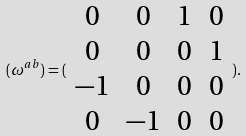<formula> <loc_0><loc_0><loc_500><loc_500>( \omega ^ { a b } ) = ( \begin{array} { c c c c } 0 & 0 & 1 & 0 \\ 0 & 0 & 0 & 1 \\ - 1 & 0 & 0 & 0 \\ 0 & - 1 & 0 & 0 \end{array} ) .</formula> 